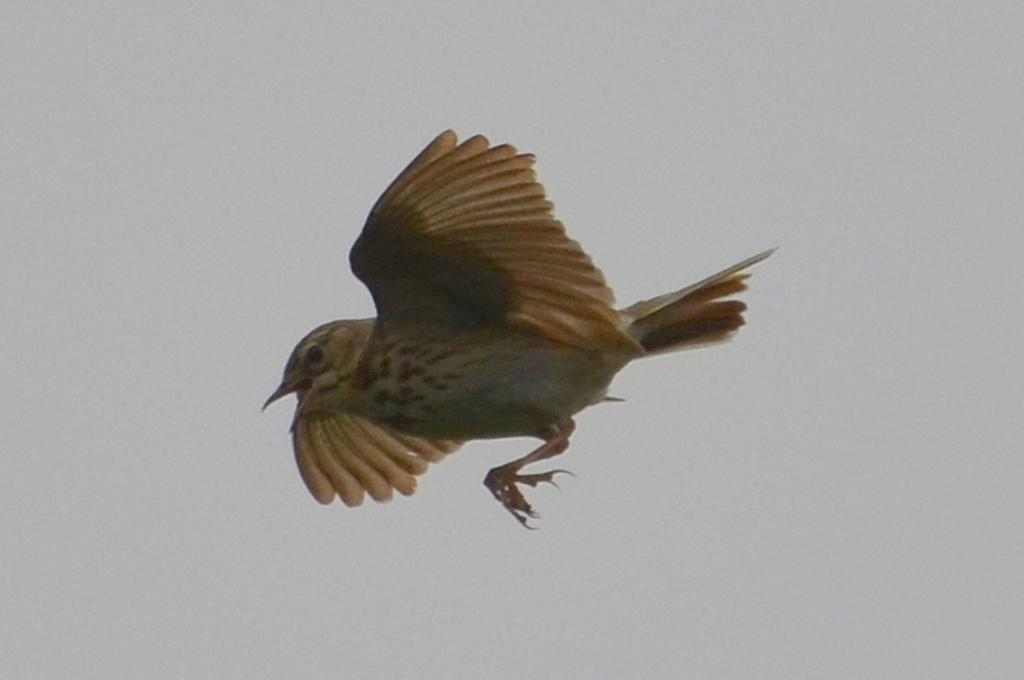What type of animal can be seen in the image? There is a bird in the image. What is the bird doing in the image? The bird is flying in the air. What can be seen in the background of the image? The sky is visible in the background of the image. What type of bottle can be seen hanging from the bird's beak in the image? There is no bottle present in the image; it only features a bird flying in the air with the sky visible in the background. 